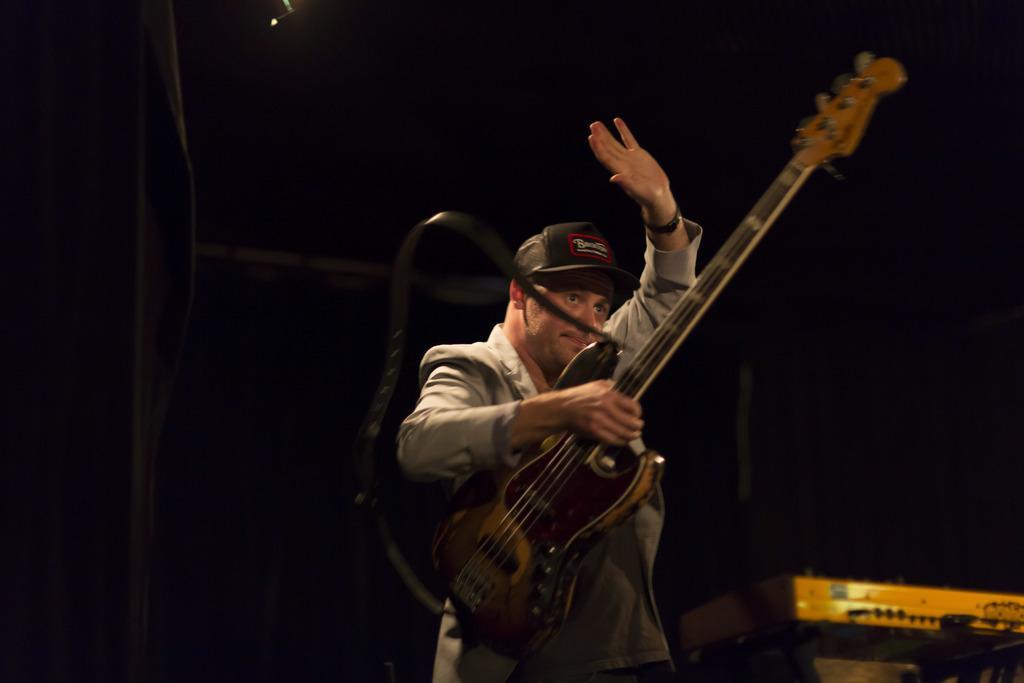Describe this image in one or two sentences. Here we see a man holding a guitar in his hand. 